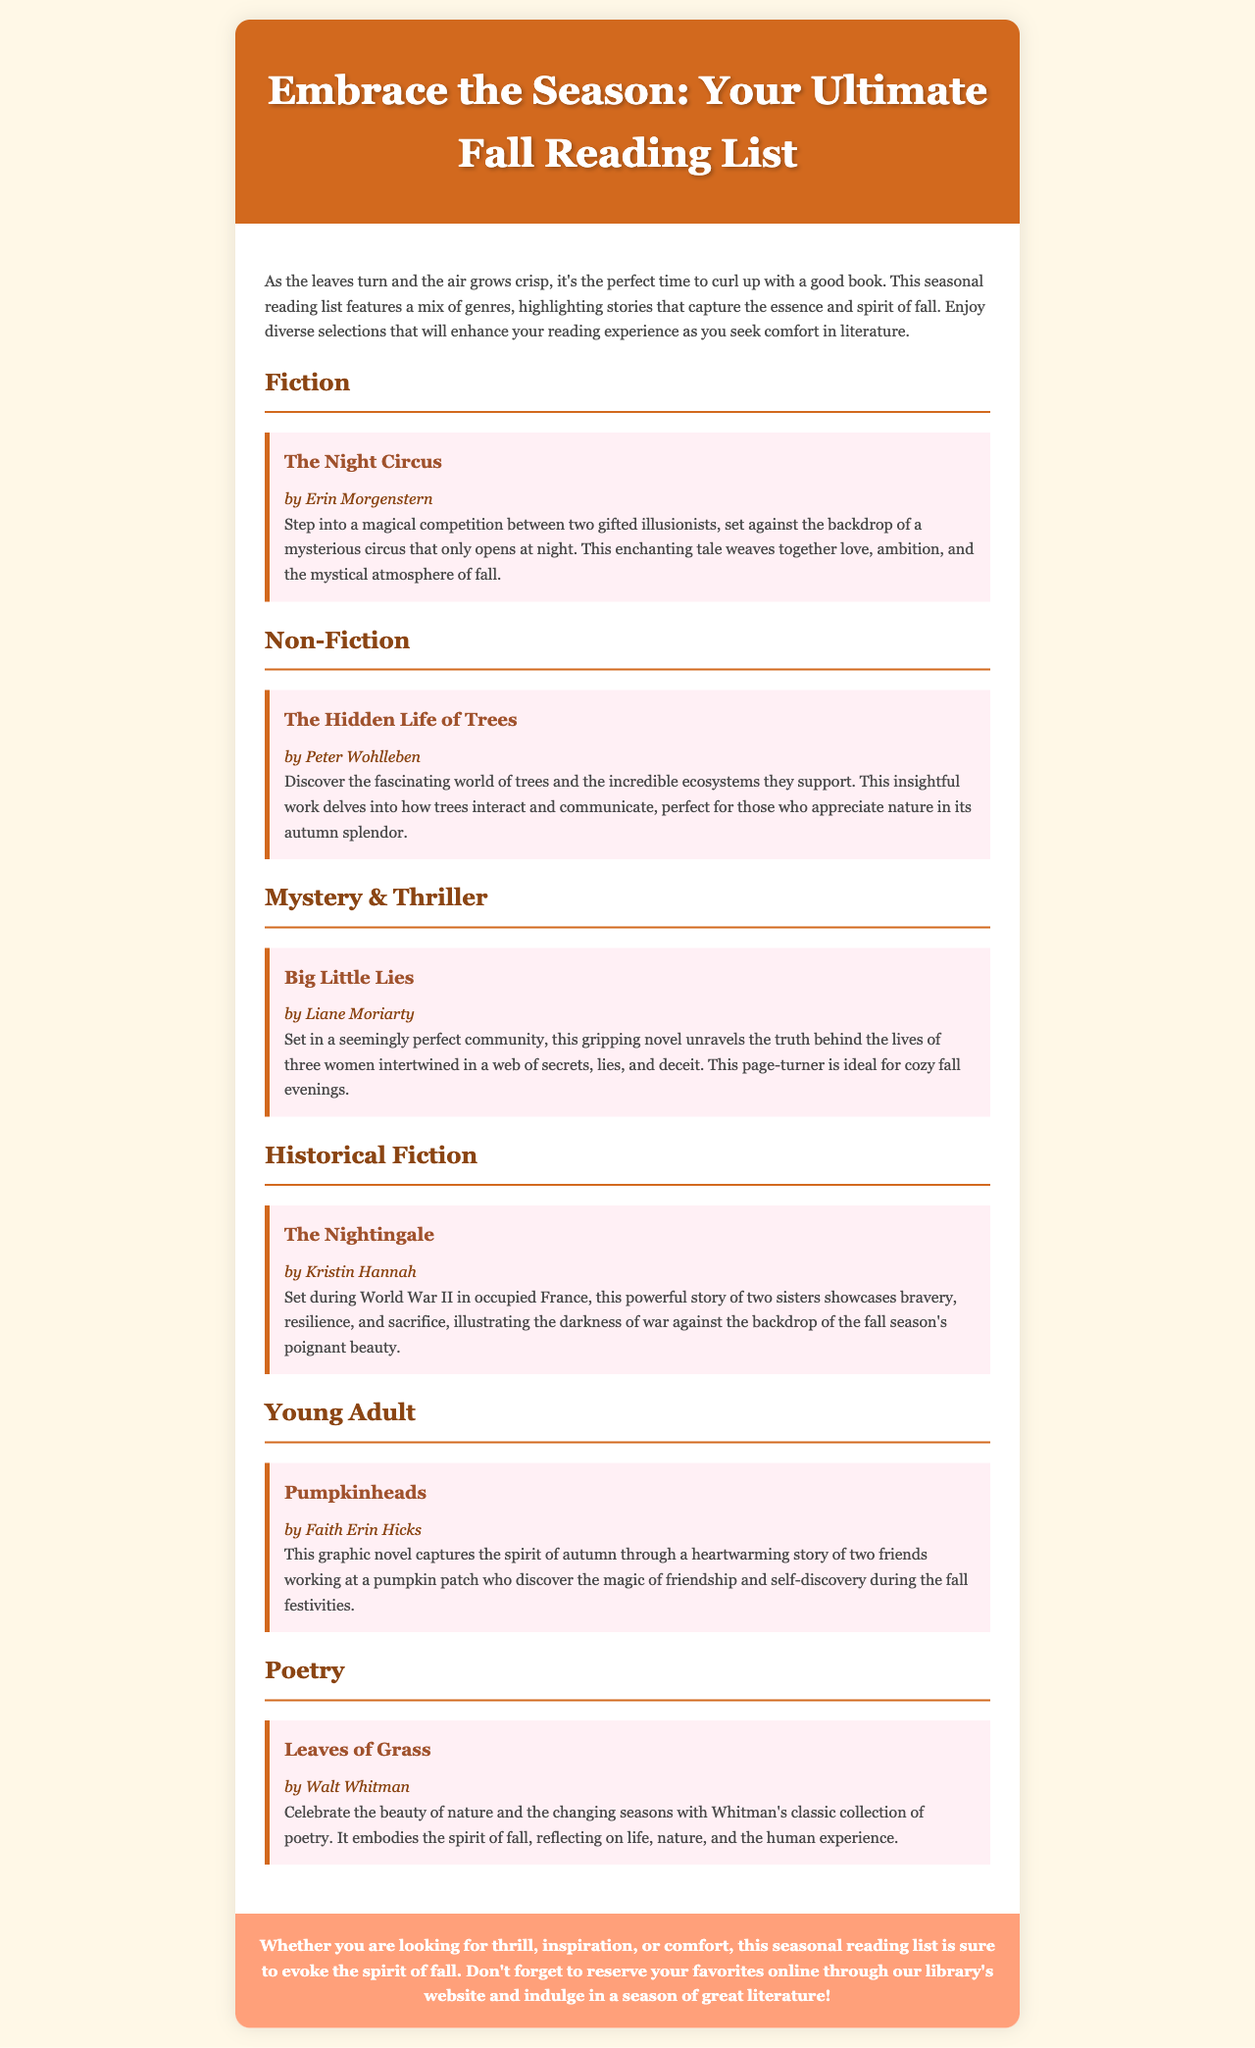What is the title of the newsletter? The title of the newsletter is prominently displayed in the header section, introducing the seasonal theme.
Answer: Embrace the Season: Your Ultimate Fall Reading List Who is the author of "The Night Circus"? The document lists the author's name immediately after the book title in a structured format.
Answer: Erin Morgenstern What genre does "The Hidden Life of Trees" belong to? The genre of the book is categorized under the specified genre section in the document.
Answer: Non-Fiction How many books are listed under the Young Adult genre? The document includes a single entry for the Young Adult genre, which is explicitly mentioned.
Answer: 1 What theme is emphasized in the seasonal reading list? The theme is highlighted in the introduction, focusing on the essence and spirit of the specific season.
Answer: Fall Which book is described as a graphic novel? The specific format of the book is mentioned in the descriptions outlining its unique characteristics.
Answer: Pumpkinheads What do the closing remarks encourage readers to do? The closing section provides a clear call-to-action related to engaging with the library's resources.
Answer: Reserve your favorites online What significant event is featured in "The Nightingale"? The document highlights a crucial historical context in which the story takes place, providing depth to the narrative.
Answer: World War II Which poem collection is mentioned in the newsletter? The document specifies a classic poetry collection as part of the selections presented in the poetry section.
Answer: Leaves of Grass 